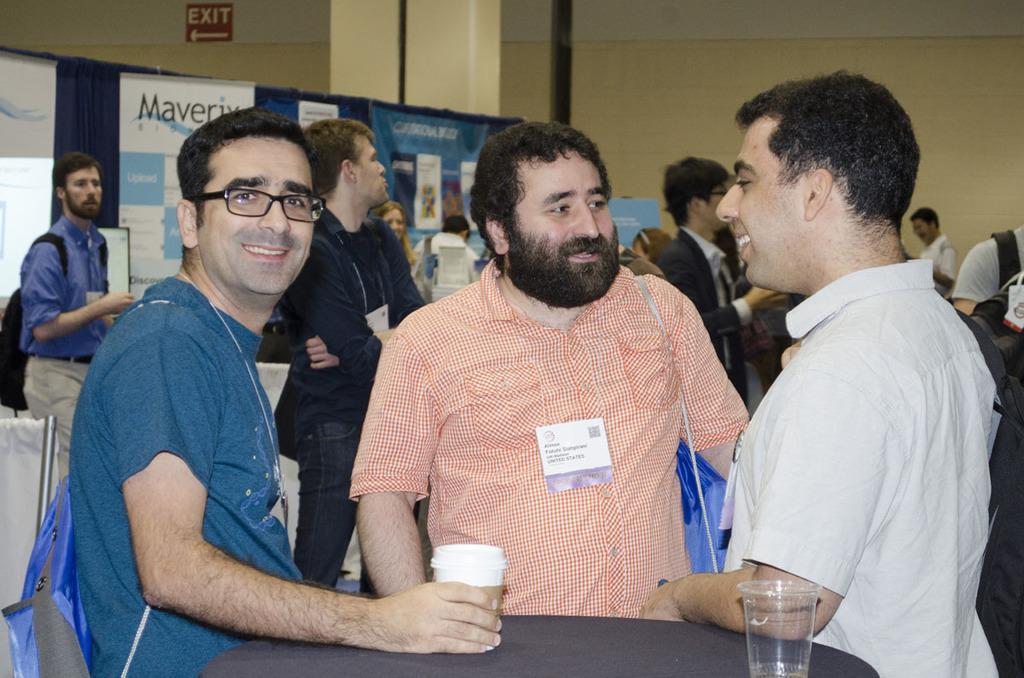Please provide a concise description of this image. In front of the picture, we see three men are standing. The man on the left side is holding a glass in his hand. Three of them are smiling. In front of them, we see a table on which two gases are placed. Behind them, we see people are standing. Behind them, we see banners in white color with some text written on it. Behind that, we see a blue color sheet. In the background, we see a wall and an exit board. On the left side, we see a projector screen. 